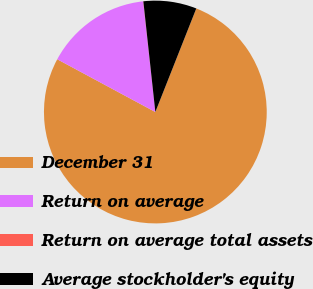Convert chart. <chart><loc_0><loc_0><loc_500><loc_500><pie_chart><fcel>December 31<fcel>Return on average<fcel>Return on average total assets<fcel>Average stockholder's equity<nl><fcel>76.86%<fcel>15.4%<fcel>0.03%<fcel>7.71%<nl></chart> 